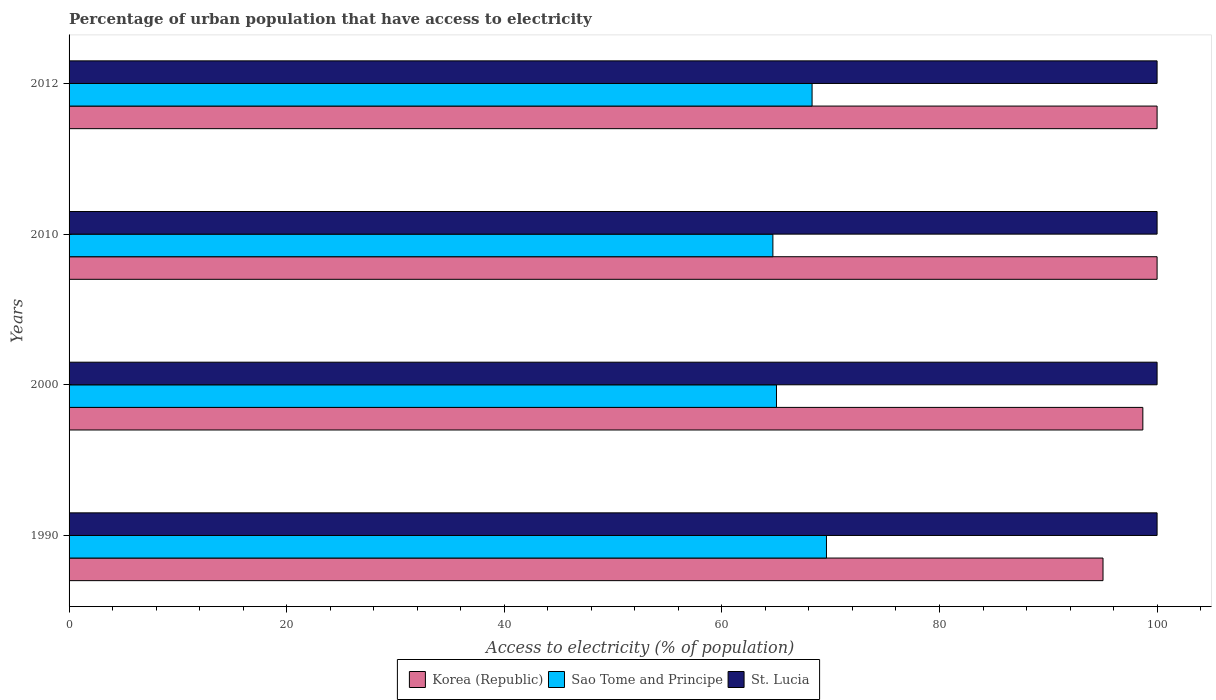How many different coloured bars are there?
Provide a short and direct response. 3. Are the number of bars on each tick of the Y-axis equal?
Your answer should be compact. Yes. How many bars are there on the 3rd tick from the top?
Your response must be concise. 3. In how many cases, is the number of bars for a given year not equal to the number of legend labels?
Ensure brevity in your answer.  0. What is the percentage of urban population that have access to electricity in Korea (Republic) in 2010?
Your answer should be very brief. 100. Across all years, what is the minimum percentage of urban population that have access to electricity in St. Lucia?
Ensure brevity in your answer.  100. In which year was the percentage of urban population that have access to electricity in Korea (Republic) minimum?
Give a very brief answer. 1990. What is the total percentage of urban population that have access to electricity in St. Lucia in the graph?
Provide a succinct answer. 400. What is the difference between the percentage of urban population that have access to electricity in St. Lucia in 1990 and the percentage of urban population that have access to electricity in Sao Tome and Principe in 2012?
Your answer should be compact. 31.71. What is the average percentage of urban population that have access to electricity in Sao Tome and Principe per year?
Provide a succinct answer. 66.9. In the year 2000, what is the difference between the percentage of urban population that have access to electricity in Sao Tome and Principe and percentage of urban population that have access to electricity in Korea (Republic)?
Keep it short and to the point. -33.67. What is the ratio of the percentage of urban population that have access to electricity in Korea (Republic) in 1990 to that in 2010?
Provide a short and direct response. 0.95. Is the percentage of urban population that have access to electricity in St. Lucia in 1990 less than that in 2012?
Keep it short and to the point. No. Is the difference between the percentage of urban population that have access to electricity in Sao Tome and Principe in 1990 and 2010 greater than the difference between the percentage of urban population that have access to electricity in Korea (Republic) in 1990 and 2010?
Offer a very short reply. Yes. What is the difference between the highest and the second highest percentage of urban population that have access to electricity in St. Lucia?
Make the answer very short. 0. What is the difference between the highest and the lowest percentage of urban population that have access to electricity in Sao Tome and Principe?
Offer a very short reply. 4.92. What does the 1st bar from the bottom in 1990 represents?
Your answer should be very brief. Korea (Republic). Does the graph contain any zero values?
Your response must be concise. No. Does the graph contain grids?
Your answer should be very brief. No. Where does the legend appear in the graph?
Offer a terse response. Bottom center. How many legend labels are there?
Keep it short and to the point. 3. What is the title of the graph?
Keep it short and to the point. Percentage of urban population that have access to electricity. Does "Ethiopia" appear as one of the legend labels in the graph?
Your response must be concise. No. What is the label or title of the X-axis?
Offer a terse response. Access to electricity (% of population). What is the Access to electricity (% of population) of Korea (Republic) in 1990?
Offer a very short reply. 95.03. What is the Access to electricity (% of population) in Sao Tome and Principe in 1990?
Offer a terse response. 69.61. What is the Access to electricity (% of population) of Korea (Republic) in 2000?
Offer a very short reply. 98.69. What is the Access to electricity (% of population) in Sao Tome and Principe in 2000?
Make the answer very short. 65.02. What is the Access to electricity (% of population) of St. Lucia in 2000?
Provide a succinct answer. 100. What is the Access to electricity (% of population) of Sao Tome and Principe in 2010?
Your answer should be very brief. 64.69. What is the Access to electricity (% of population) of St. Lucia in 2010?
Provide a succinct answer. 100. What is the Access to electricity (% of population) in Sao Tome and Principe in 2012?
Your answer should be compact. 68.29. Across all years, what is the maximum Access to electricity (% of population) in Korea (Republic)?
Your answer should be very brief. 100. Across all years, what is the maximum Access to electricity (% of population) of Sao Tome and Principe?
Provide a short and direct response. 69.61. Across all years, what is the maximum Access to electricity (% of population) in St. Lucia?
Provide a succinct answer. 100. Across all years, what is the minimum Access to electricity (% of population) in Korea (Republic)?
Your answer should be compact. 95.03. Across all years, what is the minimum Access to electricity (% of population) of Sao Tome and Principe?
Keep it short and to the point. 64.69. What is the total Access to electricity (% of population) of Korea (Republic) in the graph?
Provide a short and direct response. 393.72. What is the total Access to electricity (% of population) of Sao Tome and Principe in the graph?
Provide a short and direct response. 267.61. What is the difference between the Access to electricity (% of population) of Korea (Republic) in 1990 and that in 2000?
Make the answer very short. -3.66. What is the difference between the Access to electricity (% of population) of Sao Tome and Principe in 1990 and that in 2000?
Provide a short and direct response. 4.59. What is the difference between the Access to electricity (% of population) in St. Lucia in 1990 and that in 2000?
Offer a very short reply. 0. What is the difference between the Access to electricity (% of population) in Korea (Republic) in 1990 and that in 2010?
Keep it short and to the point. -4.97. What is the difference between the Access to electricity (% of population) of Sao Tome and Principe in 1990 and that in 2010?
Make the answer very short. 4.92. What is the difference between the Access to electricity (% of population) of St. Lucia in 1990 and that in 2010?
Offer a terse response. 0. What is the difference between the Access to electricity (% of population) in Korea (Republic) in 1990 and that in 2012?
Provide a succinct answer. -4.97. What is the difference between the Access to electricity (% of population) of Sao Tome and Principe in 1990 and that in 2012?
Your response must be concise. 1.32. What is the difference between the Access to electricity (% of population) of St. Lucia in 1990 and that in 2012?
Keep it short and to the point. 0. What is the difference between the Access to electricity (% of population) of Korea (Republic) in 2000 and that in 2010?
Make the answer very short. -1.31. What is the difference between the Access to electricity (% of population) of Sao Tome and Principe in 2000 and that in 2010?
Offer a terse response. 0.33. What is the difference between the Access to electricity (% of population) of Korea (Republic) in 2000 and that in 2012?
Offer a terse response. -1.31. What is the difference between the Access to electricity (% of population) in Sao Tome and Principe in 2000 and that in 2012?
Give a very brief answer. -3.27. What is the difference between the Access to electricity (% of population) in St. Lucia in 2000 and that in 2012?
Your response must be concise. 0. What is the difference between the Access to electricity (% of population) of Sao Tome and Principe in 2010 and that in 2012?
Your answer should be compact. -3.6. What is the difference between the Access to electricity (% of population) of Korea (Republic) in 1990 and the Access to electricity (% of population) of Sao Tome and Principe in 2000?
Ensure brevity in your answer.  30.01. What is the difference between the Access to electricity (% of population) in Korea (Republic) in 1990 and the Access to electricity (% of population) in St. Lucia in 2000?
Your answer should be very brief. -4.97. What is the difference between the Access to electricity (% of population) in Sao Tome and Principe in 1990 and the Access to electricity (% of population) in St. Lucia in 2000?
Provide a succinct answer. -30.39. What is the difference between the Access to electricity (% of population) of Korea (Republic) in 1990 and the Access to electricity (% of population) of Sao Tome and Principe in 2010?
Offer a terse response. 30.34. What is the difference between the Access to electricity (% of population) in Korea (Republic) in 1990 and the Access to electricity (% of population) in St. Lucia in 2010?
Make the answer very short. -4.97. What is the difference between the Access to electricity (% of population) of Sao Tome and Principe in 1990 and the Access to electricity (% of population) of St. Lucia in 2010?
Offer a terse response. -30.39. What is the difference between the Access to electricity (% of population) in Korea (Republic) in 1990 and the Access to electricity (% of population) in Sao Tome and Principe in 2012?
Give a very brief answer. 26.74. What is the difference between the Access to electricity (% of population) of Korea (Republic) in 1990 and the Access to electricity (% of population) of St. Lucia in 2012?
Offer a terse response. -4.97. What is the difference between the Access to electricity (% of population) in Sao Tome and Principe in 1990 and the Access to electricity (% of population) in St. Lucia in 2012?
Ensure brevity in your answer.  -30.39. What is the difference between the Access to electricity (% of population) in Korea (Republic) in 2000 and the Access to electricity (% of population) in Sao Tome and Principe in 2010?
Make the answer very short. 34. What is the difference between the Access to electricity (% of population) of Korea (Republic) in 2000 and the Access to electricity (% of population) of St. Lucia in 2010?
Give a very brief answer. -1.31. What is the difference between the Access to electricity (% of population) of Sao Tome and Principe in 2000 and the Access to electricity (% of population) of St. Lucia in 2010?
Provide a short and direct response. -34.98. What is the difference between the Access to electricity (% of population) of Korea (Republic) in 2000 and the Access to electricity (% of population) of Sao Tome and Principe in 2012?
Ensure brevity in your answer.  30.4. What is the difference between the Access to electricity (% of population) of Korea (Republic) in 2000 and the Access to electricity (% of population) of St. Lucia in 2012?
Give a very brief answer. -1.31. What is the difference between the Access to electricity (% of population) of Sao Tome and Principe in 2000 and the Access to electricity (% of population) of St. Lucia in 2012?
Your answer should be compact. -34.98. What is the difference between the Access to electricity (% of population) of Korea (Republic) in 2010 and the Access to electricity (% of population) of Sao Tome and Principe in 2012?
Provide a short and direct response. 31.71. What is the difference between the Access to electricity (% of population) in Korea (Republic) in 2010 and the Access to electricity (% of population) in St. Lucia in 2012?
Provide a short and direct response. 0. What is the difference between the Access to electricity (% of population) in Sao Tome and Principe in 2010 and the Access to electricity (% of population) in St. Lucia in 2012?
Offer a terse response. -35.31. What is the average Access to electricity (% of population) of Korea (Republic) per year?
Your answer should be very brief. 98.43. What is the average Access to electricity (% of population) of Sao Tome and Principe per year?
Offer a terse response. 66.9. In the year 1990, what is the difference between the Access to electricity (% of population) of Korea (Republic) and Access to electricity (% of population) of Sao Tome and Principe?
Keep it short and to the point. 25.42. In the year 1990, what is the difference between the Access to electricity (% of population) in Korea (Republic) and Access to electricity (% of population) in St. Lucia?
Keep it short and to the point. -4.97. In the year 1990, what is the difference between the Access to electricity (% of population) in Sao Tome and Principe and Access to electricity (% of population) in St. Lucia?
Provide a short and direct response. -30.39. In the year 2000, what is the difference between the Access to electricity (% of population) of Korea (Republic) and Access to electricity (% of population) of Sao Tome and Principe?
Give a very brief answer. 33.67. In the year 2000, what is the difference between the Access to electricity (% of population) in Korea (Republic) and Access to electricity (% of population) in St. Lucia?
Ensure brevity in your answer.  -1.31. In the year 2000, what is the difference between the Access to electricity (% of population) of Sao Tome and Principe and Access to electricity (% of population) of St. Lucia?
Your answer should be compact. -34.98. In the year 2010, what is the difference between the Access to electricity (% of population) of Korea (Republic) and Access to electricity (% of population) of Sao Tome and Principe?
Offer a terse response. 35.31. In the year 2010, what is the difference between the Access to electricity (% of population) of Sao Tome and Principe and Access to electricity (% of population) of St. Lucia?
Your response must be concise. -35.31. In the year 2012, what is the difference between the Access to electricity (% of population) in Korea (Republic) and Access to electricity (% of population) in Sao Tome and Principe?
Keep it short and to the point. 31.71. In the year 2012, what is the difference between the Access to electricity (% of population) in Korea (Republic) and Access to electricity (% of population) in St. Lucia?
Your response must be concise. 0. In the year 2012, what is the difference between the Access to electricity (% of population) in Sao Tome and Principe and Access to electricity (% of population) in St. Lucia?
Keep it short and to the point. -31.71. What is the ratio of the Access to electricity (% of population) of Korea (Republic) in 1990 to that in 2000?
Offer a terse response. 0.96. What is the ratio of the Access to electricity (% of population) of Sao Tome and Principe in 1990 to that in 2000?
Provide a succinct answer. 1.07. What is the ratio of the Access to electricity (% of population) in St. Lucia in 1990 to that in 2000?
Keep it short and to the point. 1. What is the ratio of the Access to electricity (% of population) of Korea (Republic) in 1990 to that in 2010?
Offer a very short reply. 0.95. What is the ratio of the Access to electricity (% of population) of Sao Tome and Principe in 1990 to that in 2010?
Provide a short and direct response. 1.08. What is the ratio of the Access to electricity (% of population) of Korea (Republic) in 1990 to that in 2012?
Your answer should be very brief. 0.95. What is the ratio of the Access to electricity (% of population) of Sao Tome and Principe in 1990 to that in 2012?
Make the answer very short. 1.02. What is the ratio of the Access to electricity (% of population) in St. Lucia in 1990 to that in 2012?
Make the answer very short. 1. What is the ratio of the Access to electricity (% of population) of Korea (Republic) in 2000 to that in 2010?
Provide a succinct answer. 0.99. What is the ratio of the Access to electricity (% of population) in Sao Tome and Principe in 2000 to that in 2010?
Give a very brief answer. 1.01. What is the ratio of the Access to electricity (% of population) of St. Lucia in 2000 to that in 2010?
Provide a succinct answer. 1. What is the ratio of the Access to electricity (% of population) of Korea (Republic) in 2000 to that in 2012?
Your answer should be compact. 0.99. What is the ratio of the Access to electricity (% of population) in Sao Tome and Principe in 2000 to that in 2012?
Provide a short and direct response. 0.95. What is the ratio of the Access to electricity (% of population) of St. Lucia in 2000 to that in 2012?
Offer a terse response. 1. What is the ratio of the Access to electricity (% of population) of Korea (Republic) in 2010 to that in 2012?
Your answer should be compact. 1. What is the ratio of the Access to electricity (% of population) in Sao Tome and Principe in 2010 to that in 2012?
Make the answer very short. 0.95. What is the ratio of the Access to electricity (% of population) of St. Lucia in 2010 to that in 2012?
Offer a very short reply. 1. What is the difference between the highest and the second highest Access to electricity (% of population) of Sao Tome and Principe?
Make the answer very short. 1.32. What is the difference between the highest and the second highest Access to electricity (% of population) of St. Lucia?
Your response must be concise. 0. What is the difference between the highest and the lowest Access to electricity (% of population) in Korea (Republic)?
Provide a succinct answer. 4.97. What is the difference between the highest and the lowest Access to electricity (% of population) of Sao Tome and Principe?
Give a very brief answer. 4.92. 